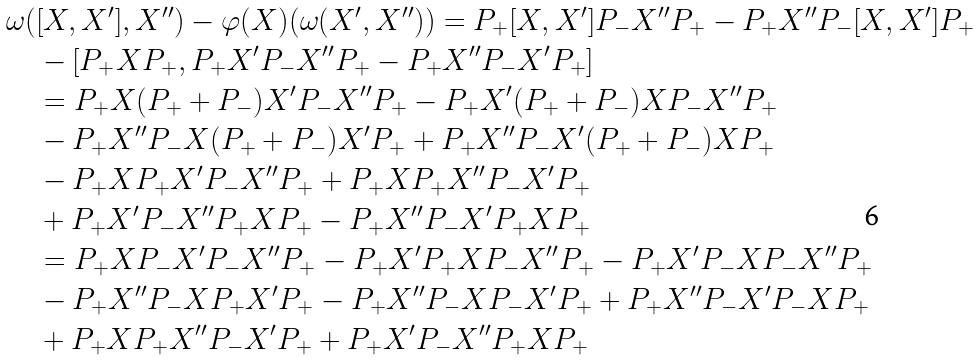<formula> <loc_0><loc_0><loc_500><loc_500>& \omega ( [ X , X ^ { \prime } ] , X ^ { \prime \prime } ) - \varphi ( X ) ( \omega ( X ^ { \prime } , X ^ { \prime \prime } ) ) = P _ { + } [ X , X ^ { \prime } ] P _ { - } X ^ { \prime \prime } P _ { + } - P _ { + } X ^ { \prime \prime } P _ { - } [ X , X ^ { \prime } ] P _ { + } \\ & \quad - [ P _ { + } X P _ { + } , P _ { + } X ^ { \prime } P _ { - } X ^ { \prime \prime } P _ { + } - P _ { + } X ^ { \prime \prime } P _ { - } X ^ { \prime } P _ { + } ] \\ & \quad = P _ { + } X ( P _ { + } + P _ { - } ) X ^ { \prime } P _ { - } X ^ { \prime \prime } P _ { + } - P _ { + } X ^ { \prime } ( P _ { + } + P _ { - } ) X P _ { - } X ^ { \prime \prime } P _ { + } \\ & \quad - P _ { + } X ^ { \prime \prime } P _ { - } X ( P _ { + } + P _ { - } ) X ^ { \prime } P _ { + } + P _ { + } X ^ { \prime \prime } P _ { - } X ^ { \prime } ( P _ { + } + P _ { - } ) X P _ { + } \\ & \quad - P _ { + } X P _ { + } X ^ { \prime } P _ { - } X ^ { \prime \prime } P _ { + } + P _ { + } X P _ { + } X ^ { \prime \prime } P _ { - } X ^ { \prime } P _ { + } \\ & \quad + P _ { + } X ^ { \prime } P _ { - } X ^ { \prime \prime } P _ { + } X P _ { + } - P _ { + } X ^ { \prime \prime } P _ { - } X ^ { \prime } P _ { + } X P _ { + } \\ & \quad = P _ { + } X P _ { - } X ^ { \prime } P _ { - } X ^ { \prime \prime } P _ { + } - P _ { + } X ^ { \prime } P _ { + } X P _ { - } X ^ { \prime \prime } P _ { + } - P _ { + } X ^ { \prime } P _ { - } X P _ { - } X ^ { \prime \prime } P _ { + } \\ & \quad - P _ { + } X ^ { \prime \prime } P _ { - } X P _ { + } X ^ { \prime } P _ { + } - P _ { + } X ^ { \prime \prime } P _ { - } X P _ { - } X ^ { \prime } P _ { + } + P _ { + } X ^ { \prime \prime } P _ { - } X ^ { \prime } P _ { - } X P _ { + } \\ & \quad + P _ { + } X P _ { + } X ^ { \prime \prime } P _ { - } X ^ { \prime } P _ { + } + P _ { + } X ^ { \prime } P _ { - } X ^ { \prime \prime } P _ { + } X P _ { + }</formula> 